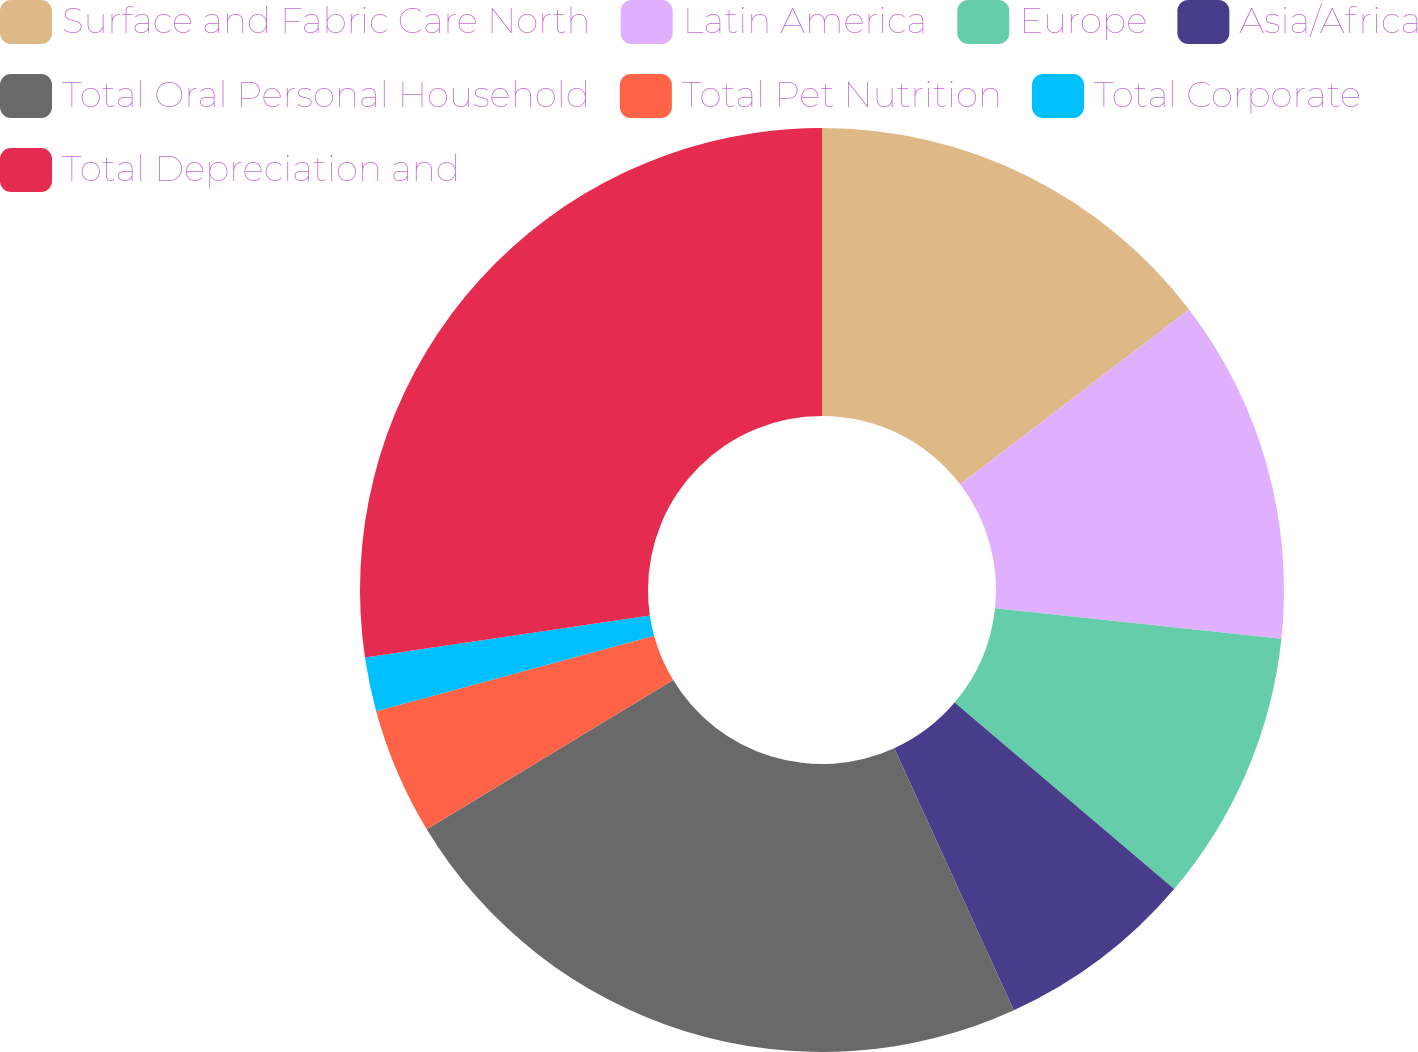<chart> <loc_0><loc_0><loc_500><loc_500><pie_chart><fcel>Surface and Fabric Care North<fcel>Latin America<fcel>Europe<fcel>Asia/Africa<fcel>Total Oral Personal Household<fcel>Total Pet Nutrition<fcel>Total Corporate<fcel>Total Depreciation and<nl><fcel>14.61%<fcel>12.07%<fcel>9.52%<fcel>6.98%<fcel>23.15%<fcel>4.44%<fcel>1.89%<fcel>27.33%<nl></chart> 